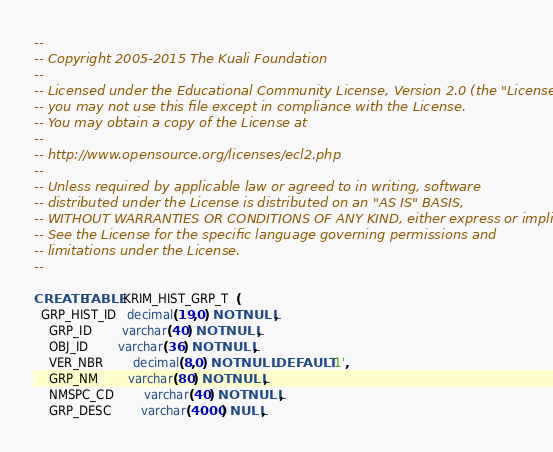Convert code to text. <code><loc_0><loc_0><loc_500><loc_500><_SQL_>--
-- Copyright 2005-2015 The Kuali Foundation
--
-- Licensed under the Educational Community License, Version 2.0 (the "License");
-- you may not use this file except in compliance with the License.
-- You may obtain a copy of the License at
--
-- http://www.opensource.org/licenses/ecl2.php
--
-- Unless required by applicable law or agreed to in writing, software
-- distributed under the License is distributed on an "AS IS" BASIS,
-- WITHOUT WARRANTIES OR CONDITIONS OF ANY KIND, either express or implied.
-- See the License for the specific language governing permissions and
-- limitations under the License.
--

CREATE TABLE KRIM_HIST_GRP_T  (
  GRP_HIST_ID   decimal(19,0) NOT NULL,
	GRP_ID      	varchar(40) NOT NULL,
	OBJ_ID      	varchar(36) NOT NULL,
	VER_NBR     	decimal(8,0) NOT NULL DEFAULT '1',
	GRP_NM      	varchar(80) NOT NULL,
	NMSPC_CD    	varchar(40) NOT NULL,
	GRP_DESC    	varchar(4000) NULL,</code> 